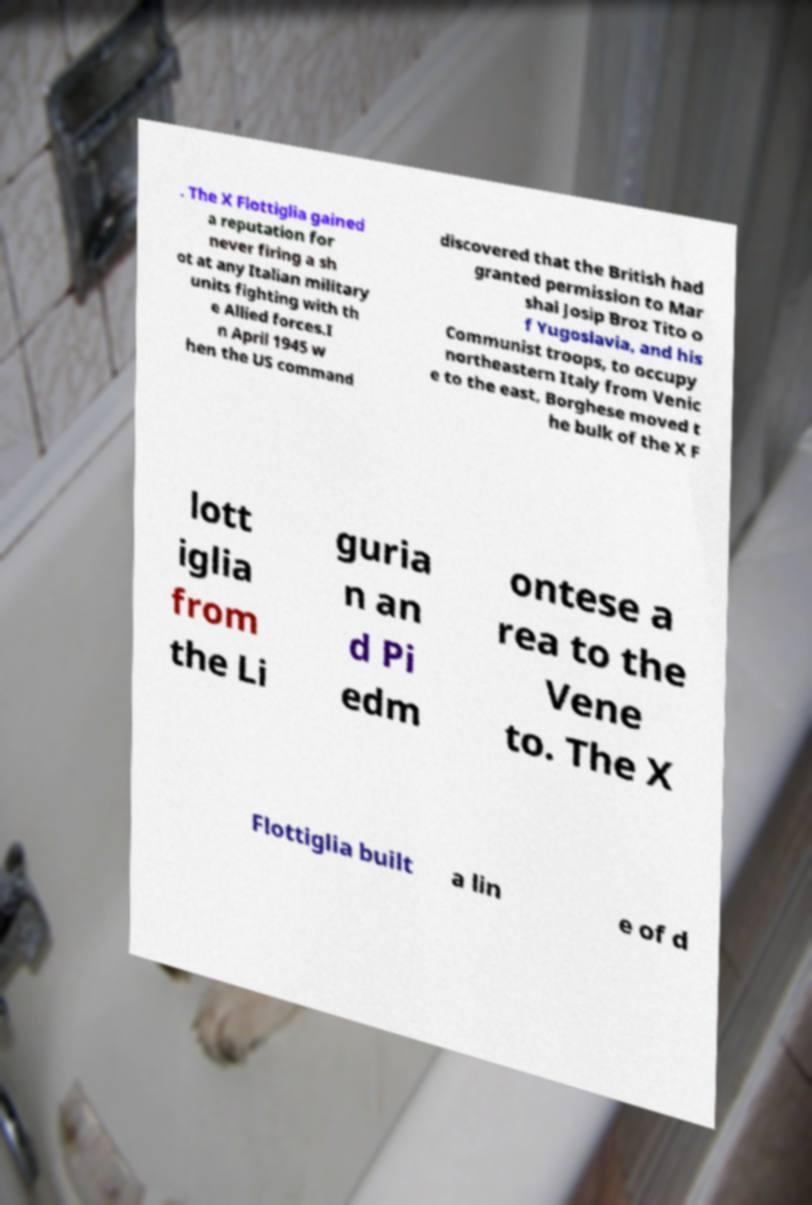Please identify and transcribe the text found in this image. . The X Flottiglia gained a reputation for never firing a sh ot at any Italian military units fighting with th e Allied forces.I n April 1945 w hen the US command discovered that the British had granted permission to Mar shal Josip Broz Tito o f Yugoslavia, and his Communist troops, to occupy northeastern Italy from Venic e to the east, Borghese moved t he bulk of the X F lott iglia from the Li guria n an d Pi edm ontese a rea to the Vene to. The X Flottiglia built a lin e of d 